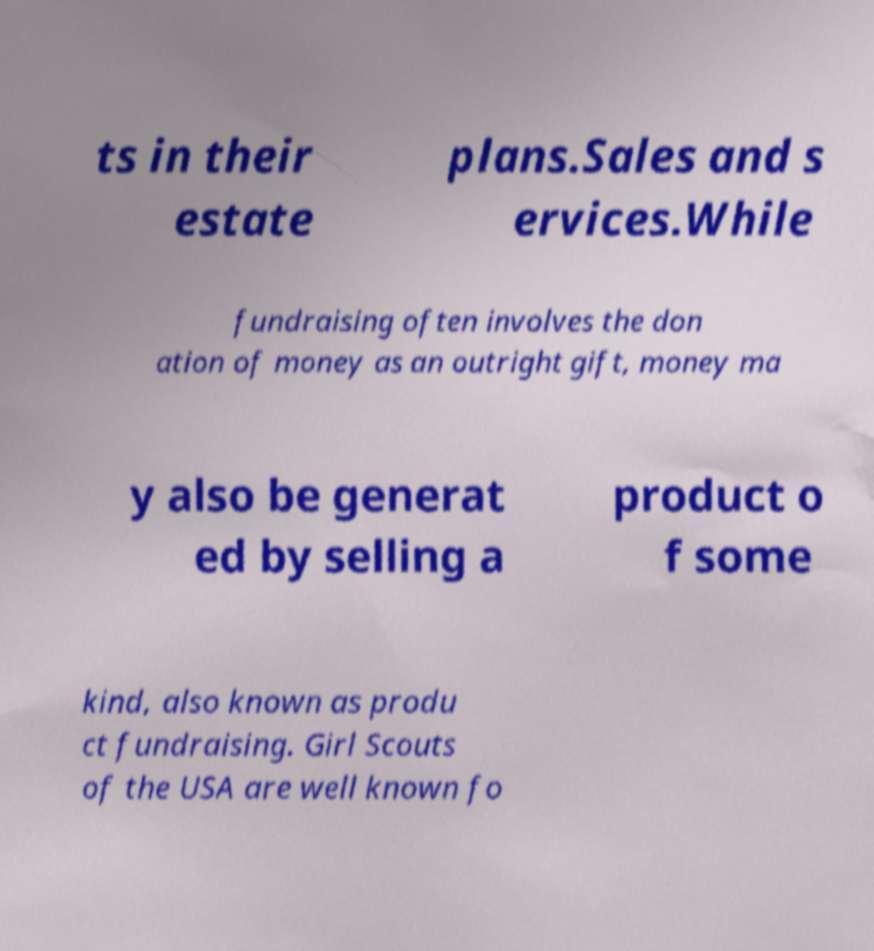I need the written content from this picture converted into text. Can you do that? ts in their estate plans.Sales and s ervices.While fundraising often involves the don ation of money as an outright gift, money ma y also be generat ed by selling a product o f some kind, also known as produ ct fundraising. Girl Scouts of the USA are well known fo 